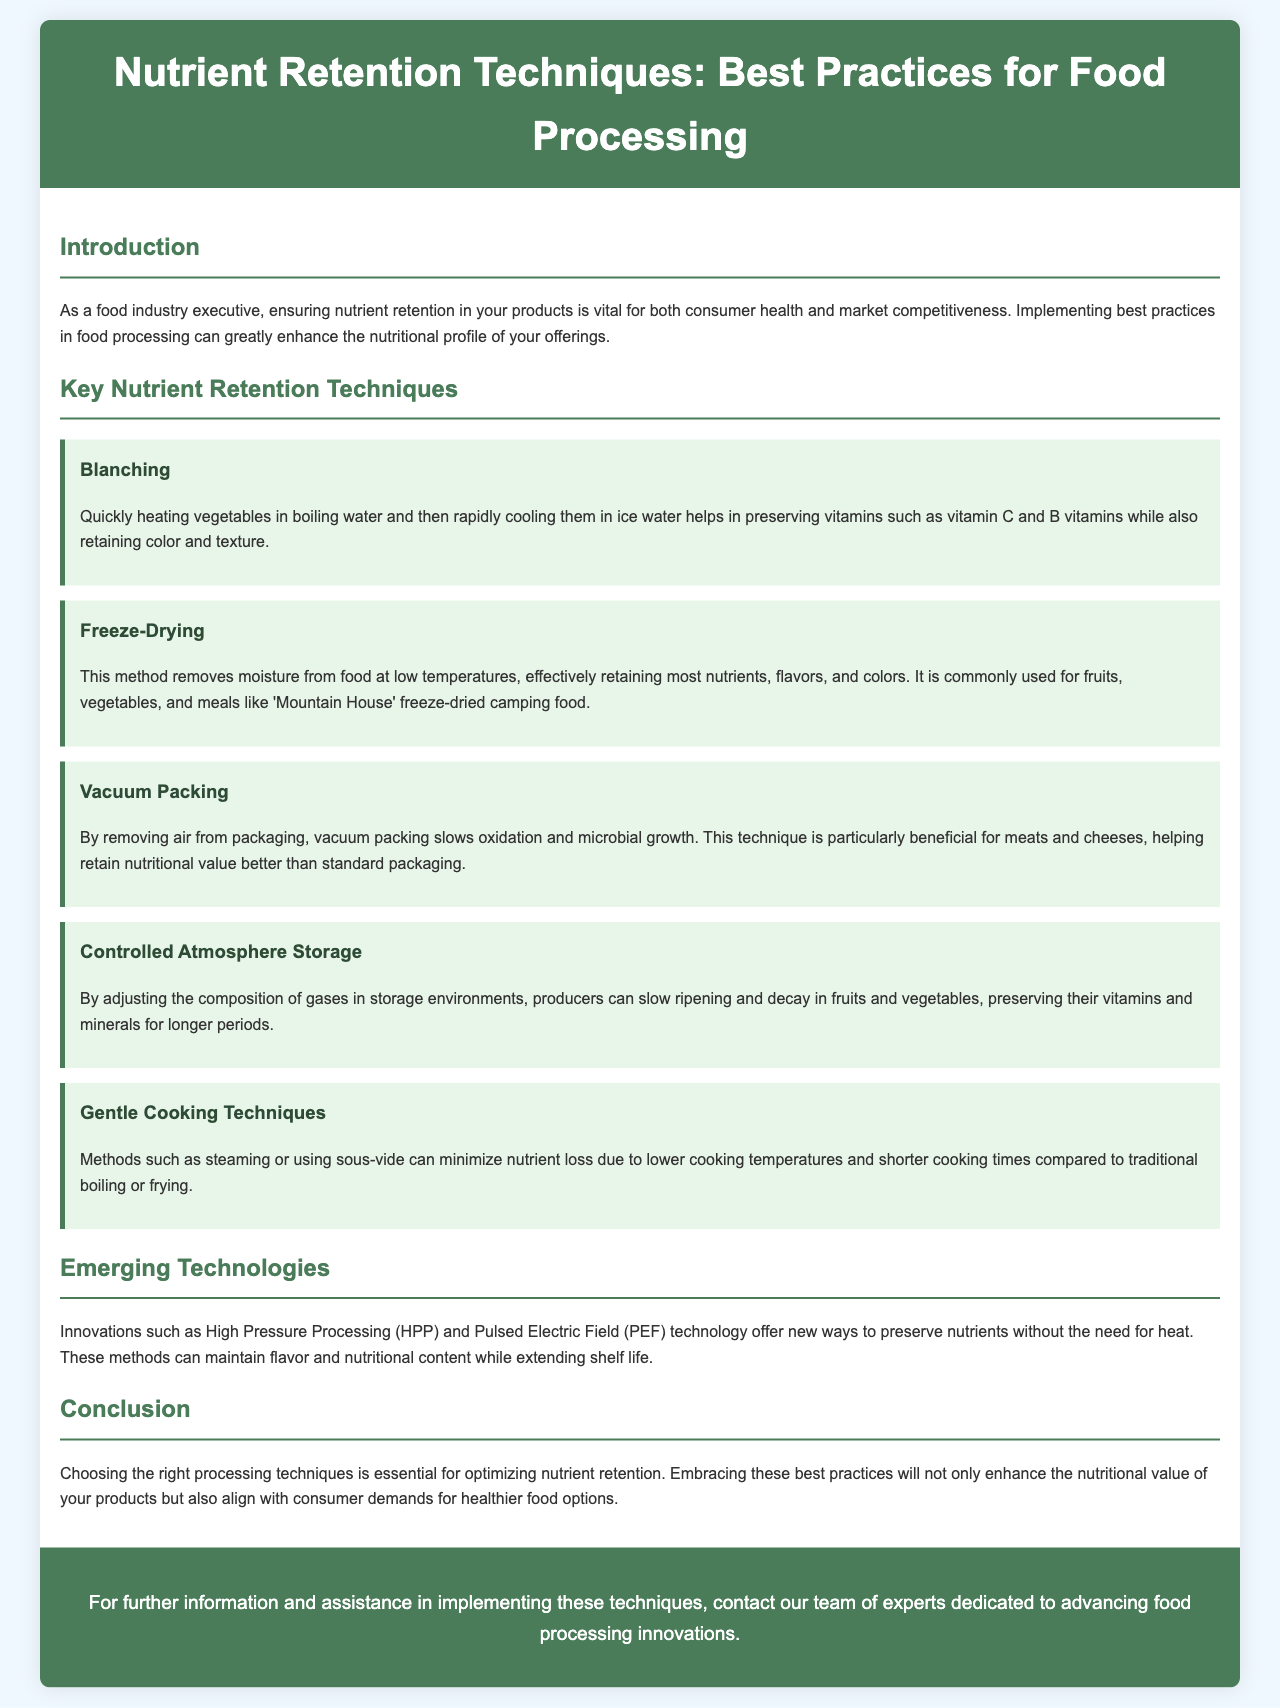What is the title of the brochure? The title is stated prominently in the header of the document.
Answer: Nutrient Retention Techniques: Best Practices for Food Processing What technique helps preserve vitamins while maintaining color and texture? This is mentioned under the section discussing key nutrient retention techniques.
Answer: Blanching What cooking method minimizes nutrient loss due to lower temperatures? This can be found in the section about gentle cooking techniques.
Answer: Steaming What emerging technology is mentioned for preserving nutrients without heat? This is specified in the section discussing innovations in food processing.
Answer: High Pressure Processing How does vacuum packing benefit meat and cheese? This is described in the section regarding vacuum packing benefits.
Answer: Retain nutritional value What is a key benefit of controlled atmosphere storage? This is summarized in the section about controlled atmosphere storage.
Answer: Preserving vitamins and minerals What does the brochure suggest about consumer demands? This is a conclusion drawn in the final section of the document.
Answer: Healthier food options What method is commonly used for freeze-dried camping food? This type of food processing is highlighted under the freeze-drying technique description.
Answer: Mountain House How does pulsed electric field technology contribute to food processing? This is outlined in the section on emerging technologies.
Answer: Maintain flavor and nutritional content 